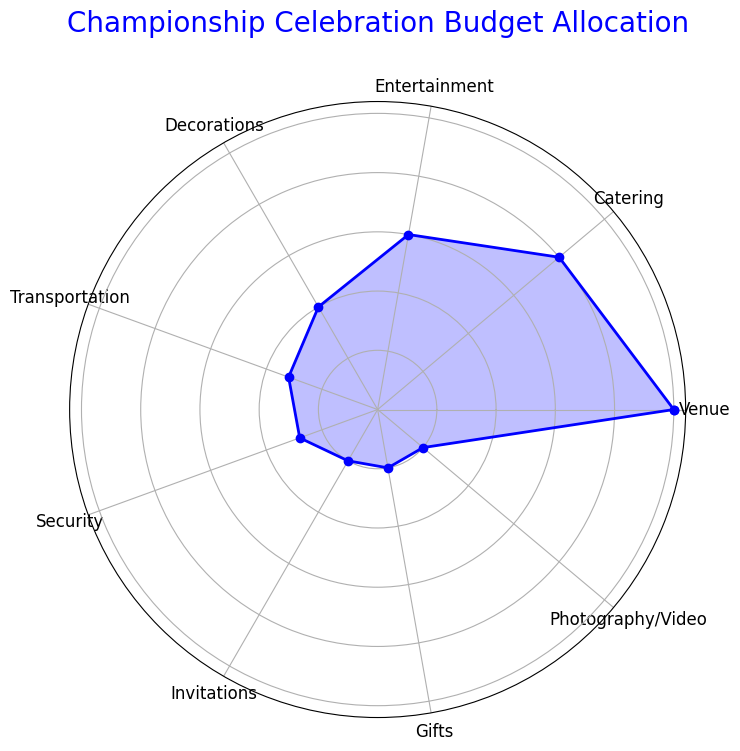Which category has the highest budget allocation? Look at the category with the largest segment on the radar chart. The 'Venue' category has the largest segment with 25%.
Answer: Venue Which category has the smallest budget allocation? Identify the category with the smallest segment on the radar chart. Both 'Invitations,' 'Gifts,' and 'Photography/Video' have the smallest segments with 5% each.
Answer: Invitations, Gifts, and Photography/Video What is the combined budget allocation for Catering, Entertainment, and Decorations? Add the percentages for Catering (20%), Entertainment (15%), and Decorations (10%). This totals to 20 + 15 + 10 = 45%.
Answer: 45% Is the budget for Transportation greater than that for Security? Compare the percentages of Transportation (8%) and Security (7%). 8% is greater than 7%.
Answer: Yes Which two categories have an equal budget allocation? Identify categories with equal segments on the radar chart. 'Invitations,' 'Gifts,' and 'Photography/Video' all share the same budget allocation of 5%.
Answer: Invitations and Gifts What percentage of the budget is allocated to non-venue-related categories? Subtract the venue-related budget from the total. Total budget is 100%, and Venue is 25%, so non-venue budget is 100% - 25% = 75%.
Answer: 75% How much more is the budget allocation for Catering compared to Security? Subtract the Security percentage from the Catering percentage. 20% - 7% = 13%.
Answer: 13% What visual feature indicates the highest budget allocation category? Look at the radar chart; the largest filled segment indicates the highest budget allocation.
Answer: The largest segment What is the average budget allocation of the top 4 categories by allocation? Identify the top 4 categories: Venue (25%), Catering (20%), Entertainment (15%), Decorations (10%). Sum and divide by 4: (25 + 20 + 15 + 10) / 4 = 70 / 4 = 17.5%.
Answer: 17.5% If you combine the budget allocation of Entertainment and Photography/Video, is it more than Catering? Add the percentages of Entertainment (15%) and Photography/Video (5%) to compare with Catering (20%). 15% + 5% = 20%.
Answer: Equal to 